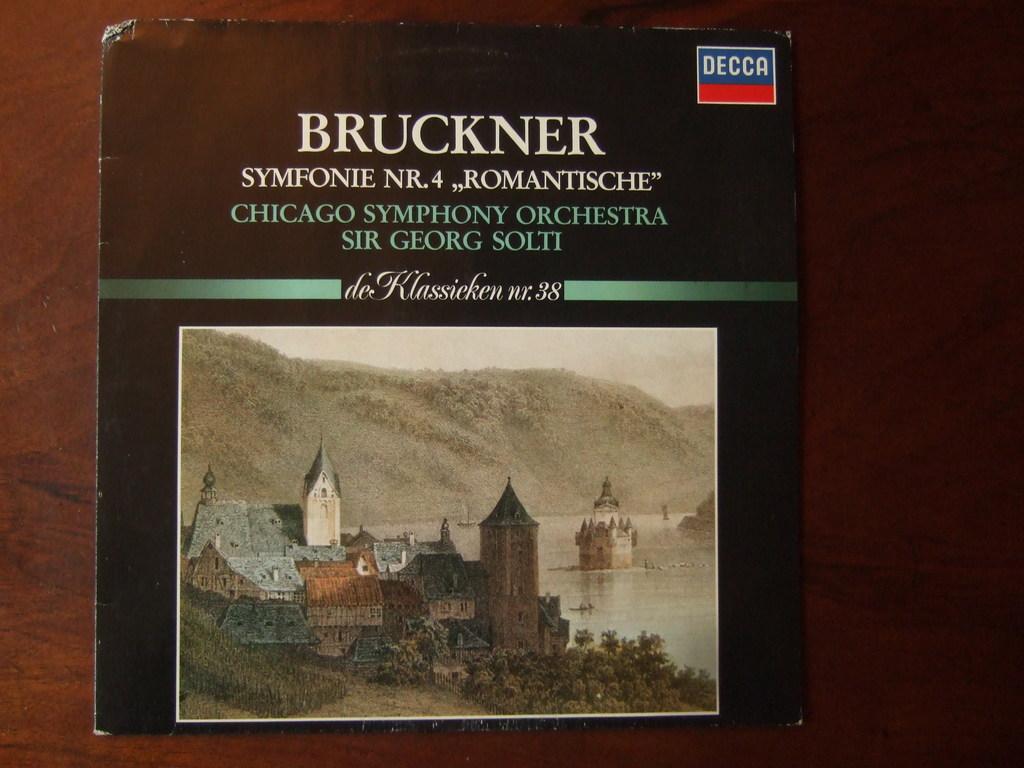What number is this book?
Your answer should be compact. 4. What is the publishing company?
Keep it short and to the point. Decca. 